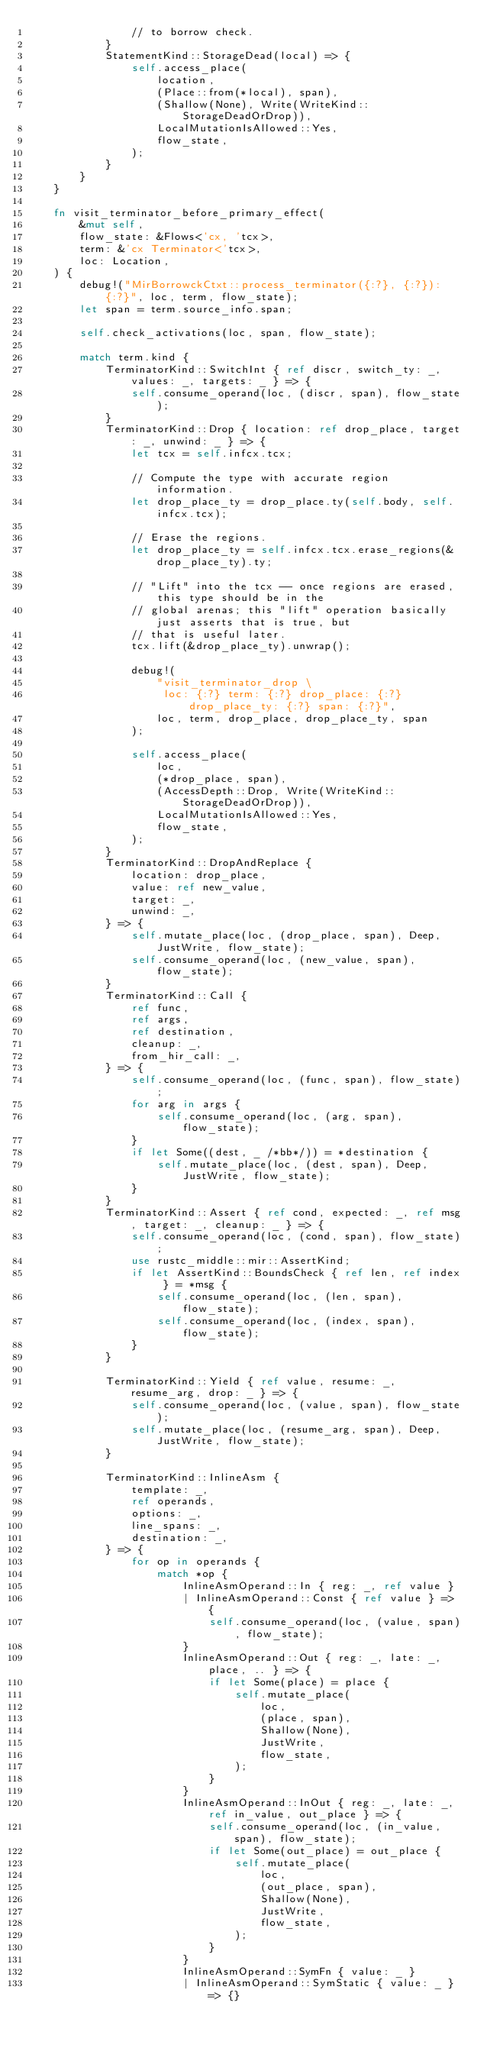Convert code to text. <code><loc_0><loc_0><loc_500><loc_500><_Rust_>                // to borrow check.
            }
            StatementKind::StorageDead(local) => {
                self.access_place(
                    location,
                    (Place::from(*local), span),
                    (Shallow(None), Write(WriteKind::StorageDeadOrDrop)),
                    LocalMutationIsAllowed::Yes,
                    flow_state,
                );
            }
        }
    }

    fn visit_terminator_before_primary_effect(
        &mut self,
        flow_state: &Flows<'cx, 'tcx>,
        term: &'cx Terminator<'tcx>,
        loc: Location,
    ) {
        debug!("MirBorrowckCtxt::process_terminator({:?}, {:?}): {:?}", loc, term, flow_state);
        let span = term.source_info.span;

        self.check_activations(loc, span, flow_state);

        match term.kind {
            TerminatorKind::SwitchInt { ref discr, switch_ty: _, values: _, targets: _ } => {
                self.consume_operand(loc, (discr, span), flow_state);
            }
            TerminatorKind::Drop { location: ref drop_place, target: _, unwind: _ } => {
                let tcx = self.infcx.tcx;

                // Compute the type with accurate region information.
                let drop_place_ty = drop_place.ty(self.body, self.infcx.tcx);

                // Erase the regions.
                let drop_place_ty = self.infcx.tcx.erase_regions(&drop_place_ty).ty;

                // "Lift" into the tcx -- once regions are erased, this type should be in the
                // global arenas; this "lift" operation basically just asserts that is true, but
                // that is useful later.
                tcx.lift(&drop_place_ty).unwrap();

                debug!(
                    "visit_terminator_drop \
                     loc: {:?} term: {:?} drop_place: {:?} drop_place_ty: {:?} span: {:?}",
                    loc, term, drop_place, drop_place_ty, span
                );

                self.access_place(
                    loc,
                    (*drop_place, span),
                    (AccessDepth::Drop, Write(WriteKind::StorageDeadOrDrop)),
                    LocalMutationIsAllowed::Yes,
                    flow_state,
                );
            }
            TerminatorKind::DropAndReplace {
                location: drop_place,
                value: ref new_value,
                target: _,
                unwind: _,
            } => {
                self.mutate_place(loc, (drop_place, span), Deep, JustWrite, flow_state);
                self.consume_operand(loc, (new_value, span), flow_state);
            }
            TerminatorKind::Call {
                ref func,
                ref args,
                ref destination,
                cleanup: _,
                from_hir_call: _,
            } => {
                self.consume_operand(loc, (func, span), flow_state);
                for arg in args {
                    self.consume_operand(loc, (arg, span), flow_state);
                }
                if let Some((dest, _ /*bb*/)) = *destination {
                    self.mutate_place(loc, (dest, span), Deep, JustWrite, flow_state);
                }
            }
            TerminatorKind::Assert { ref cond, expected: _, ref msg, target: _, cleanup: _ } => {
                self.consume_operand(loc, (cond, span), flow_state);
                use rustc_middle::mir::AssertKind;
                if let AssertKind::BoundsCheck { ref len, ref index } = *msg {
                    self.consume_operand(loc, (len, span), flow_state);
                    self.consume_operand(loc, (index, span), flow_state);
                }
            }

            TerminatorKind::Yield { ref value, resume: _, resume_arg, drop: _ } => {
                self.consume_operand(loc, (value, span), flow_state);
                self.mutate_place(loc, (resume_arg, span), Deep, JustWrite, flow_state);
            }

            TerminatorKind::InlineAsm {
                template: _,
                ref operands,
                options: _,
                line_spans: _,
                destination: _,
            } => {
                for op in operands {
                    match *op {
                        InlineAsmOperand::In { reg: _, ref value }
                        | InlineAsmOperand::Const { ref value } => {
                            self.consume_operand(loc, (value, span), flow_state);
                        }
                        InlineAsmOperand::Out { reg: _, late: _, place, .. } => {
                            if let Some(place) = place {
                                self.mutate_place(
                                    loc,
                                    (place, span),
                                    Shallow(None),
                                    JustWrite,
                                    flow_state,
                                );
                            }
                        }
                        InlineAsmOperand::InOut { reg: _, late: _, ref in_value, out_place } => {
                            self.consume_operand(loc, (in_value, span), flow_state);
                            if let Some(out_place) = out_place {
                                self.mutate_place(
                                    loc,
                                    (out_place, span),
                                    Shallow(None),
                                    JustWrite,
                                    flow_state,
                                );
                            }
                        }
                        InlineAsmOperand::SymFn { value: _ }
                        | InlineAsmOperand::SymStatic { value: _ } => {}</code> 